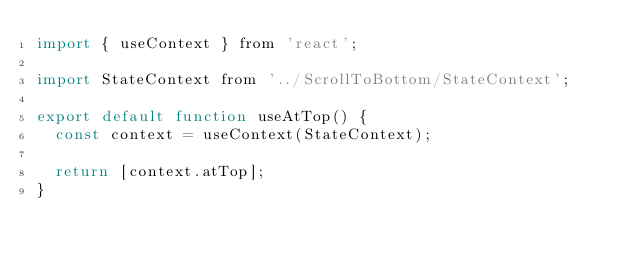<code> <loc_0><loc_0><loc_500><loc_500><_JavaScript_>import { useContext } from 'react';

import StateContext from '../ScrollToBottom/StateContext';

export default function useAtTop() {
  const context = useContext(StateContext);

  return [context.atTop];
}
</code> 